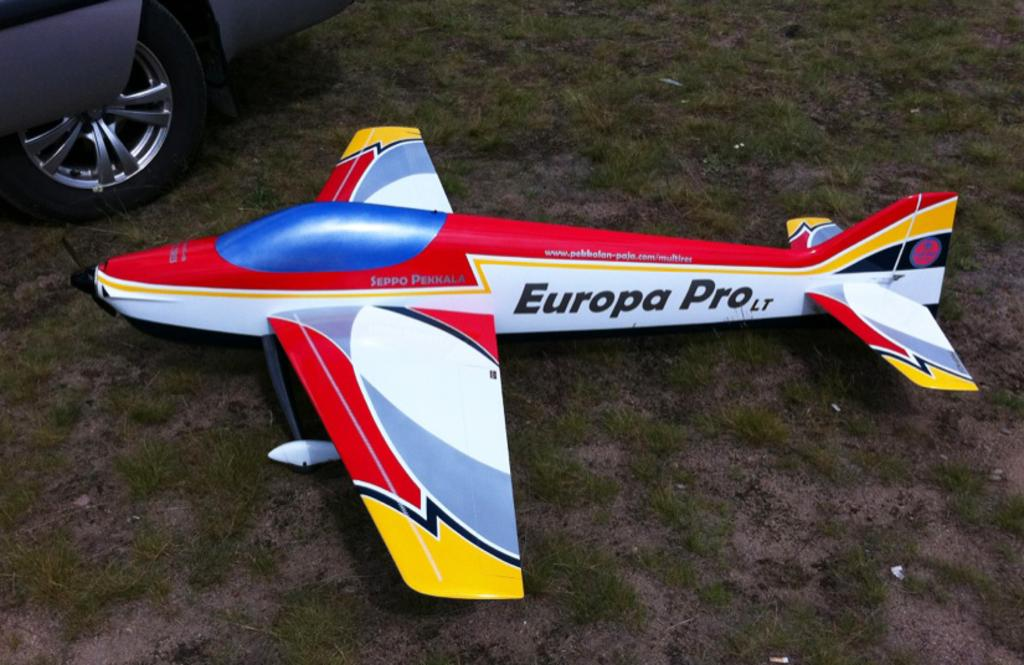<image>
Summarize the visual content of the image. A colourful model aeroplane with Europa Pro Lt written on it is on the ground next to car. 